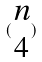<formula> <loc_0><loc_0><loc_500><loc_500>( \begin{matrix} n \\ 4 \end{matrix} )</formula> 